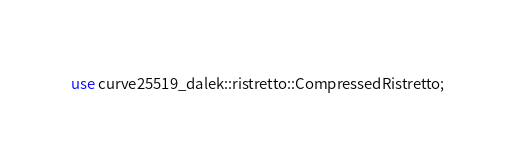<code> <loc_0><loc_0><loc_500><loc_500><_Rust_>use curve25519_dalek::ristretto::CompressedRistretto;</code> 